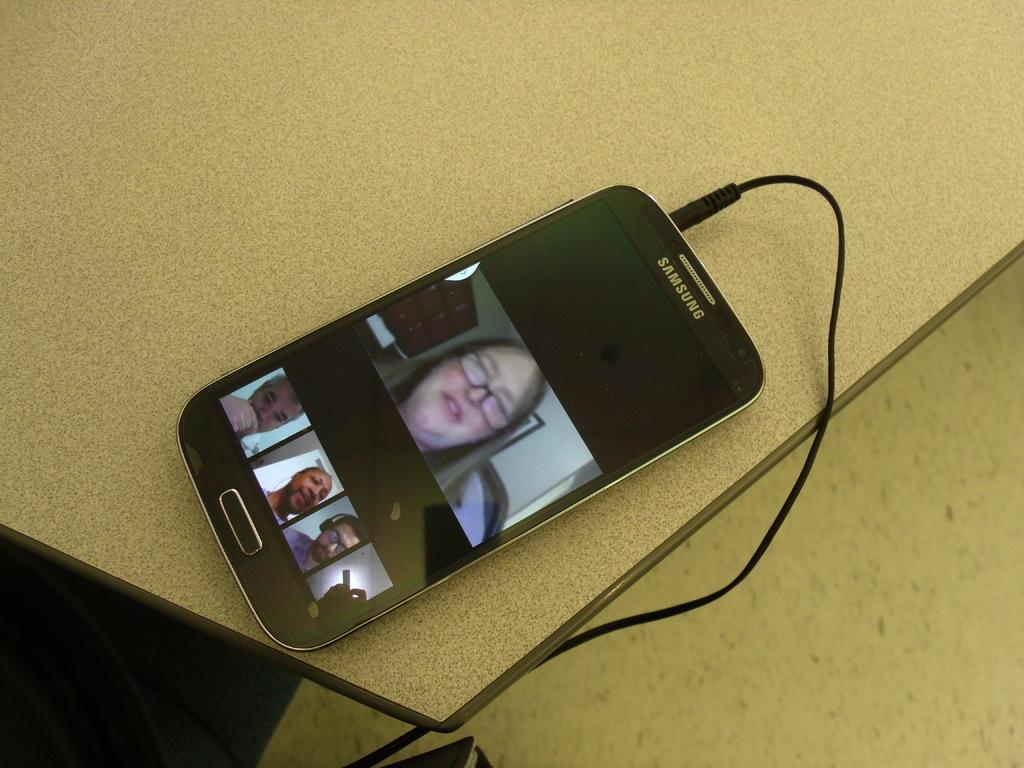<image>
Describe the image concisely. The samsung phone shown has photographs of a female and males on the screen. 